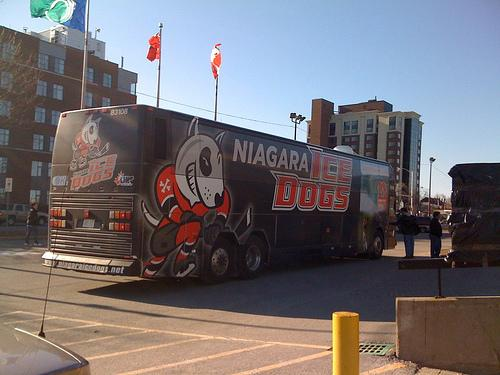What sport is the cartoon dog playing?

Choices:
A) baseball
B) ice hockey
C) golf
D) lacrosse ice hockey 